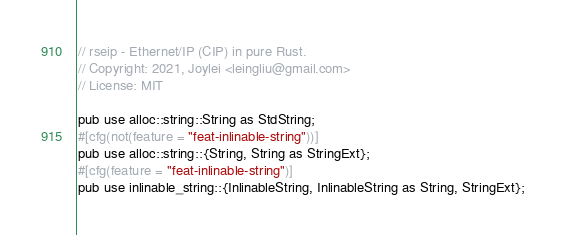Convert code to text. <code><loc_0><loc_0><loc_500><loc_500><_Rust_>// rseip - Ethernet/IP (CIP) in pure Rust.
// Copyright: 2021, Joylei <leingliu@gmail.com>
// License: MIT

pub use alloc::string::String as StdString;
#[cfg(not(feature = "feat-inlinable-string"))]
pub use alloc::string::{String, String as StringExt};
#[cfg(feature = "feat-inlinable-string")]
pub use inlinable_string::{InlinableString, InlinableString as String, StringExt};
</code> 